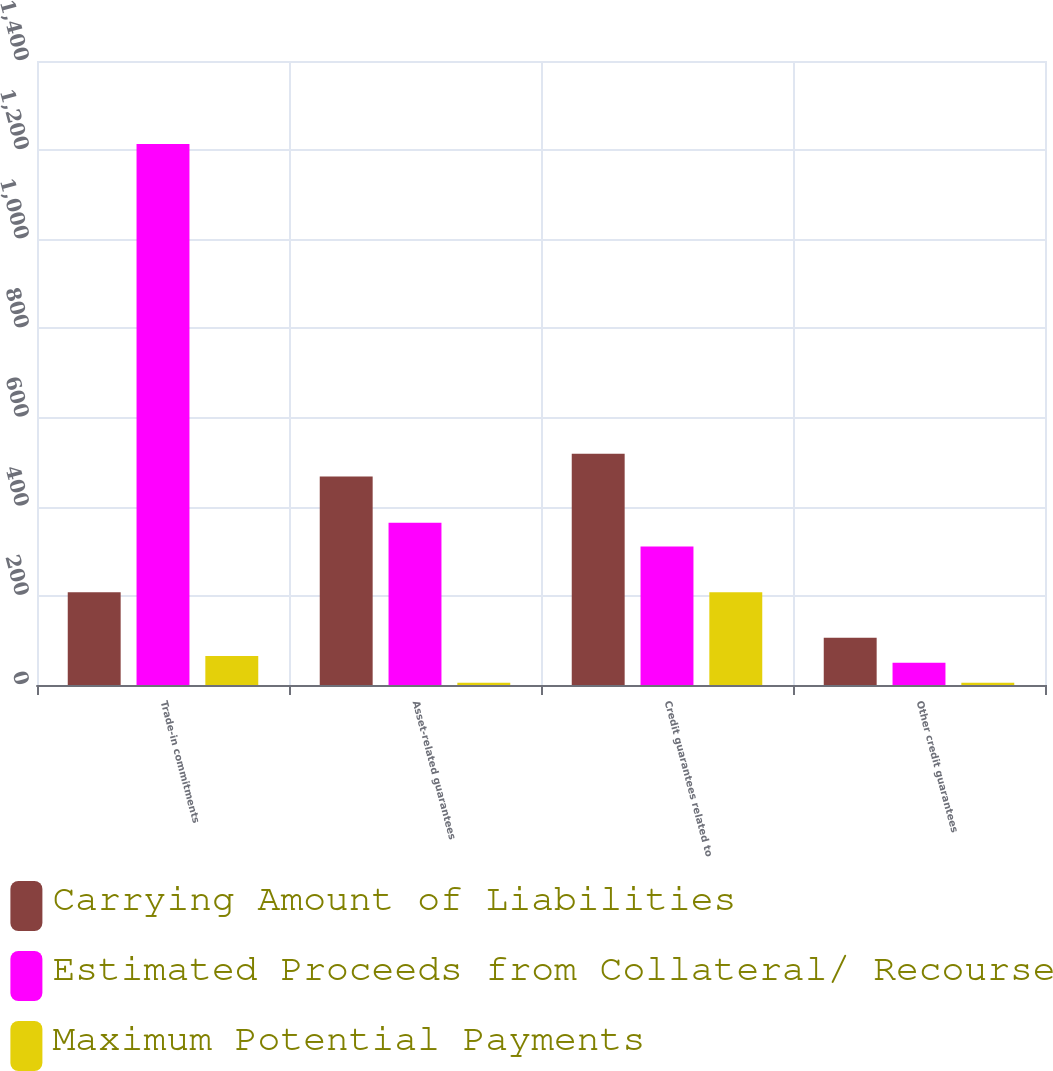Convert chart to OTSL. <chart><loc_0><loc_0><loc_500><loc_500><stacked_bar_chart><ecel><fcel>Trade-in commitments<fcel>Asset-related guarantees<fcel>Credit guarantees related to<fcel>Other credit guarantees<nl><fcel>Carrying Amount of Liabilities<fcel>208<fcel>468<fcel>519<fcel>106<nl><fcel>Estimated Proceeds from Collateral/ Recourse<fcel>1214<fcel>364<fcel>311<fcel>50<nl><fcel>Maximum Potential Payments<fcel>65<fcel>5<fcel>208<fcel>5<nl></chart> 